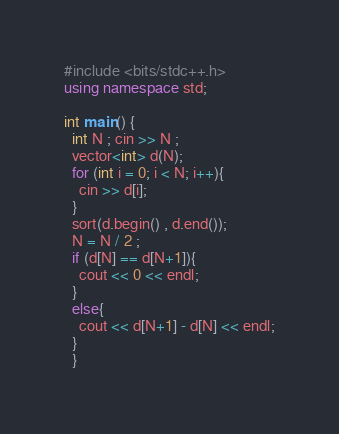Convert code to text. <code><loc_0><loc_0><loc_500><loc_500><_C++_>#include <bits/stdc++.h>
using namespace std;

int main() {
  int N ; cin >> N ;
  vector<int> d(N);
  for (int i = 0; i < N; i++){
    cin >> d[i];
  }
  sort(d.begin() , d.end());
  N = N / 2 ;
  if (d[N] == d[N+1]){
    cout << 0 << endl;
  }
  else{
    cout << d[N+1] - d[N] << endl;
  }
  }</code> 